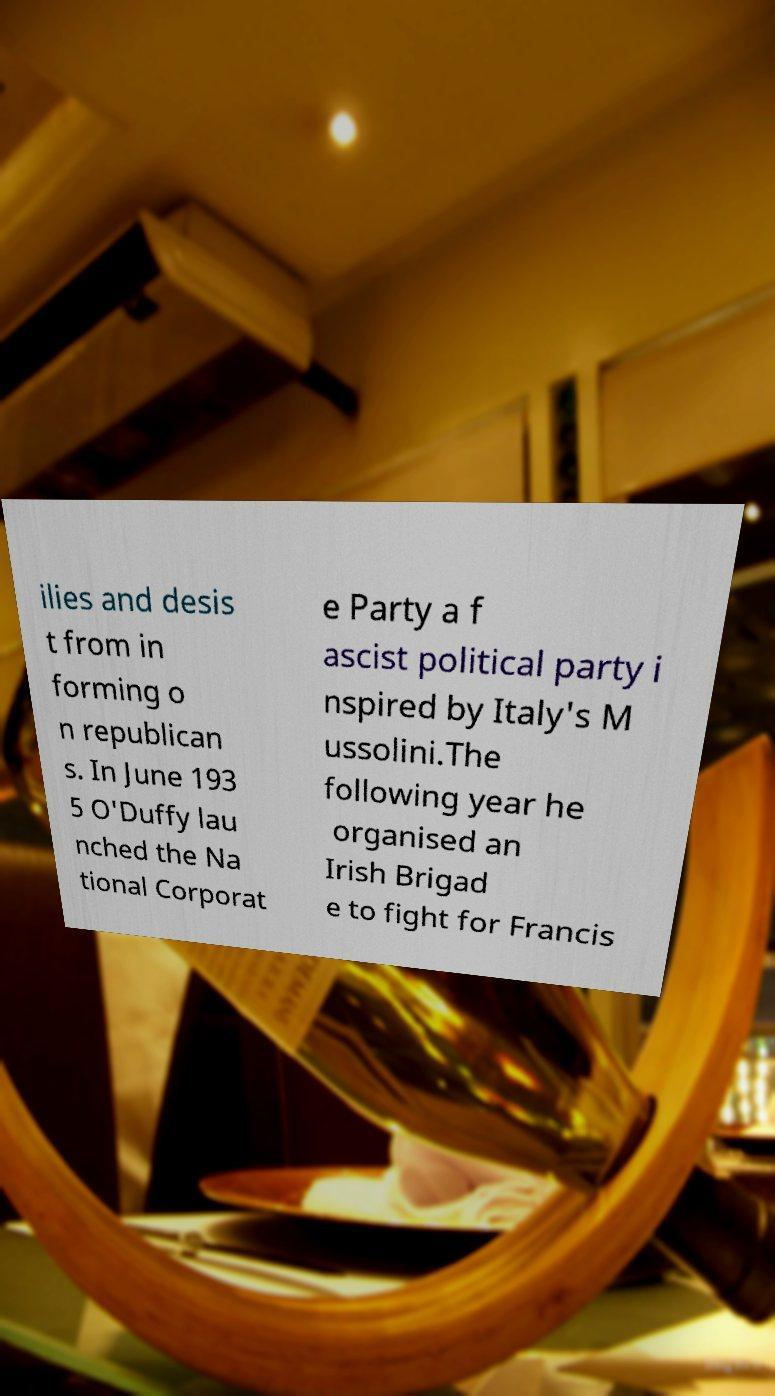Can you read and provide the text displayed in the image?This photo seems to have some interesting text. Can you extract and type it out for me? ilies and desis t from in forming o n republican s. In June 193 5 O'Duffy lau nched the Na tional Corporat e Party a f ascist political party i nspired by Italy's M ussolini.The following year he organised an Irish Brigad e to fight for Francis 